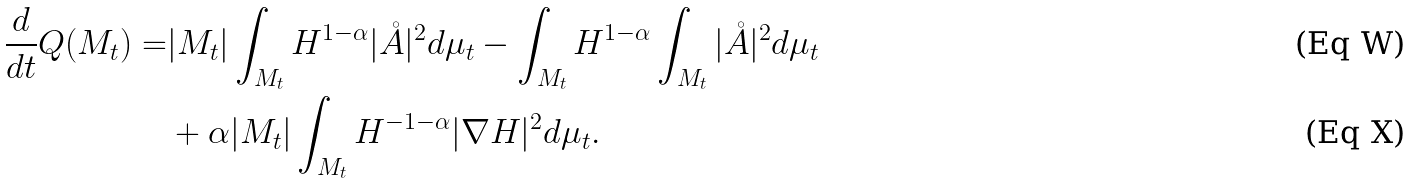<formula> <loc_0><loc_0><loc_500><loc_500>\frac { d } { d t } Q ( M _ { t } ) = & | M _ { t } | \int _ { M _ { t } } H ^ { 1 - \alpha } | \mathring { A } | ^ { 2 } d \mu _ { t } - \int _ { M _ { t } } H ^ { 1 - \alpha } \int _ { M _ { t } } | \mathring { A } | ^ { 2 } d \mu _ { t } \\ & + \alpha | M _ { t } | \int _ { M _ { t } } H ^ { - 1 - \alpha } | \nabla H | ^ { 2 } d \mu _ { t } .</formula> 